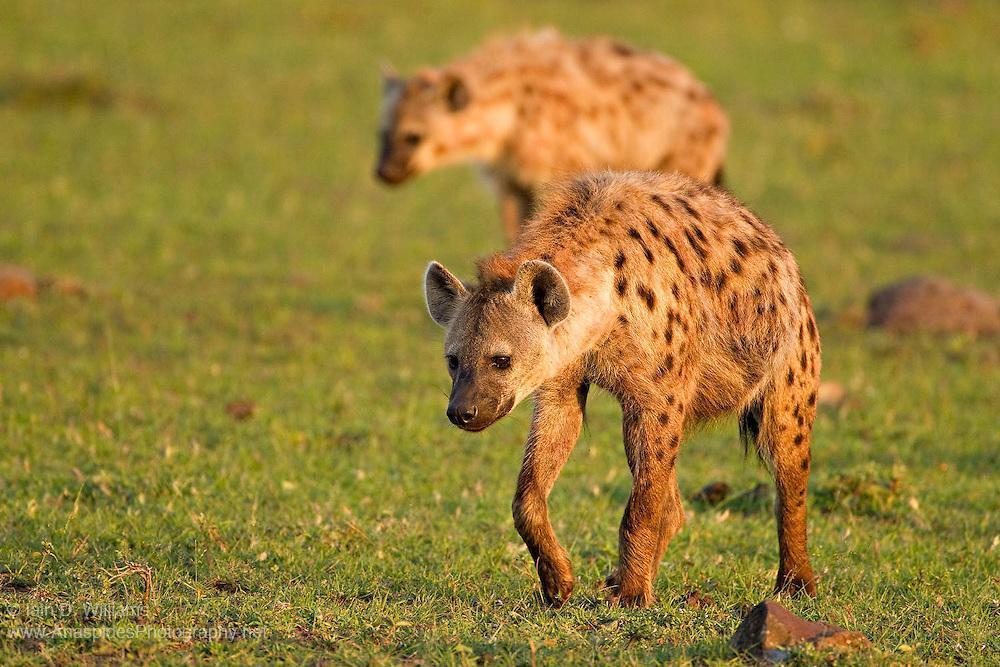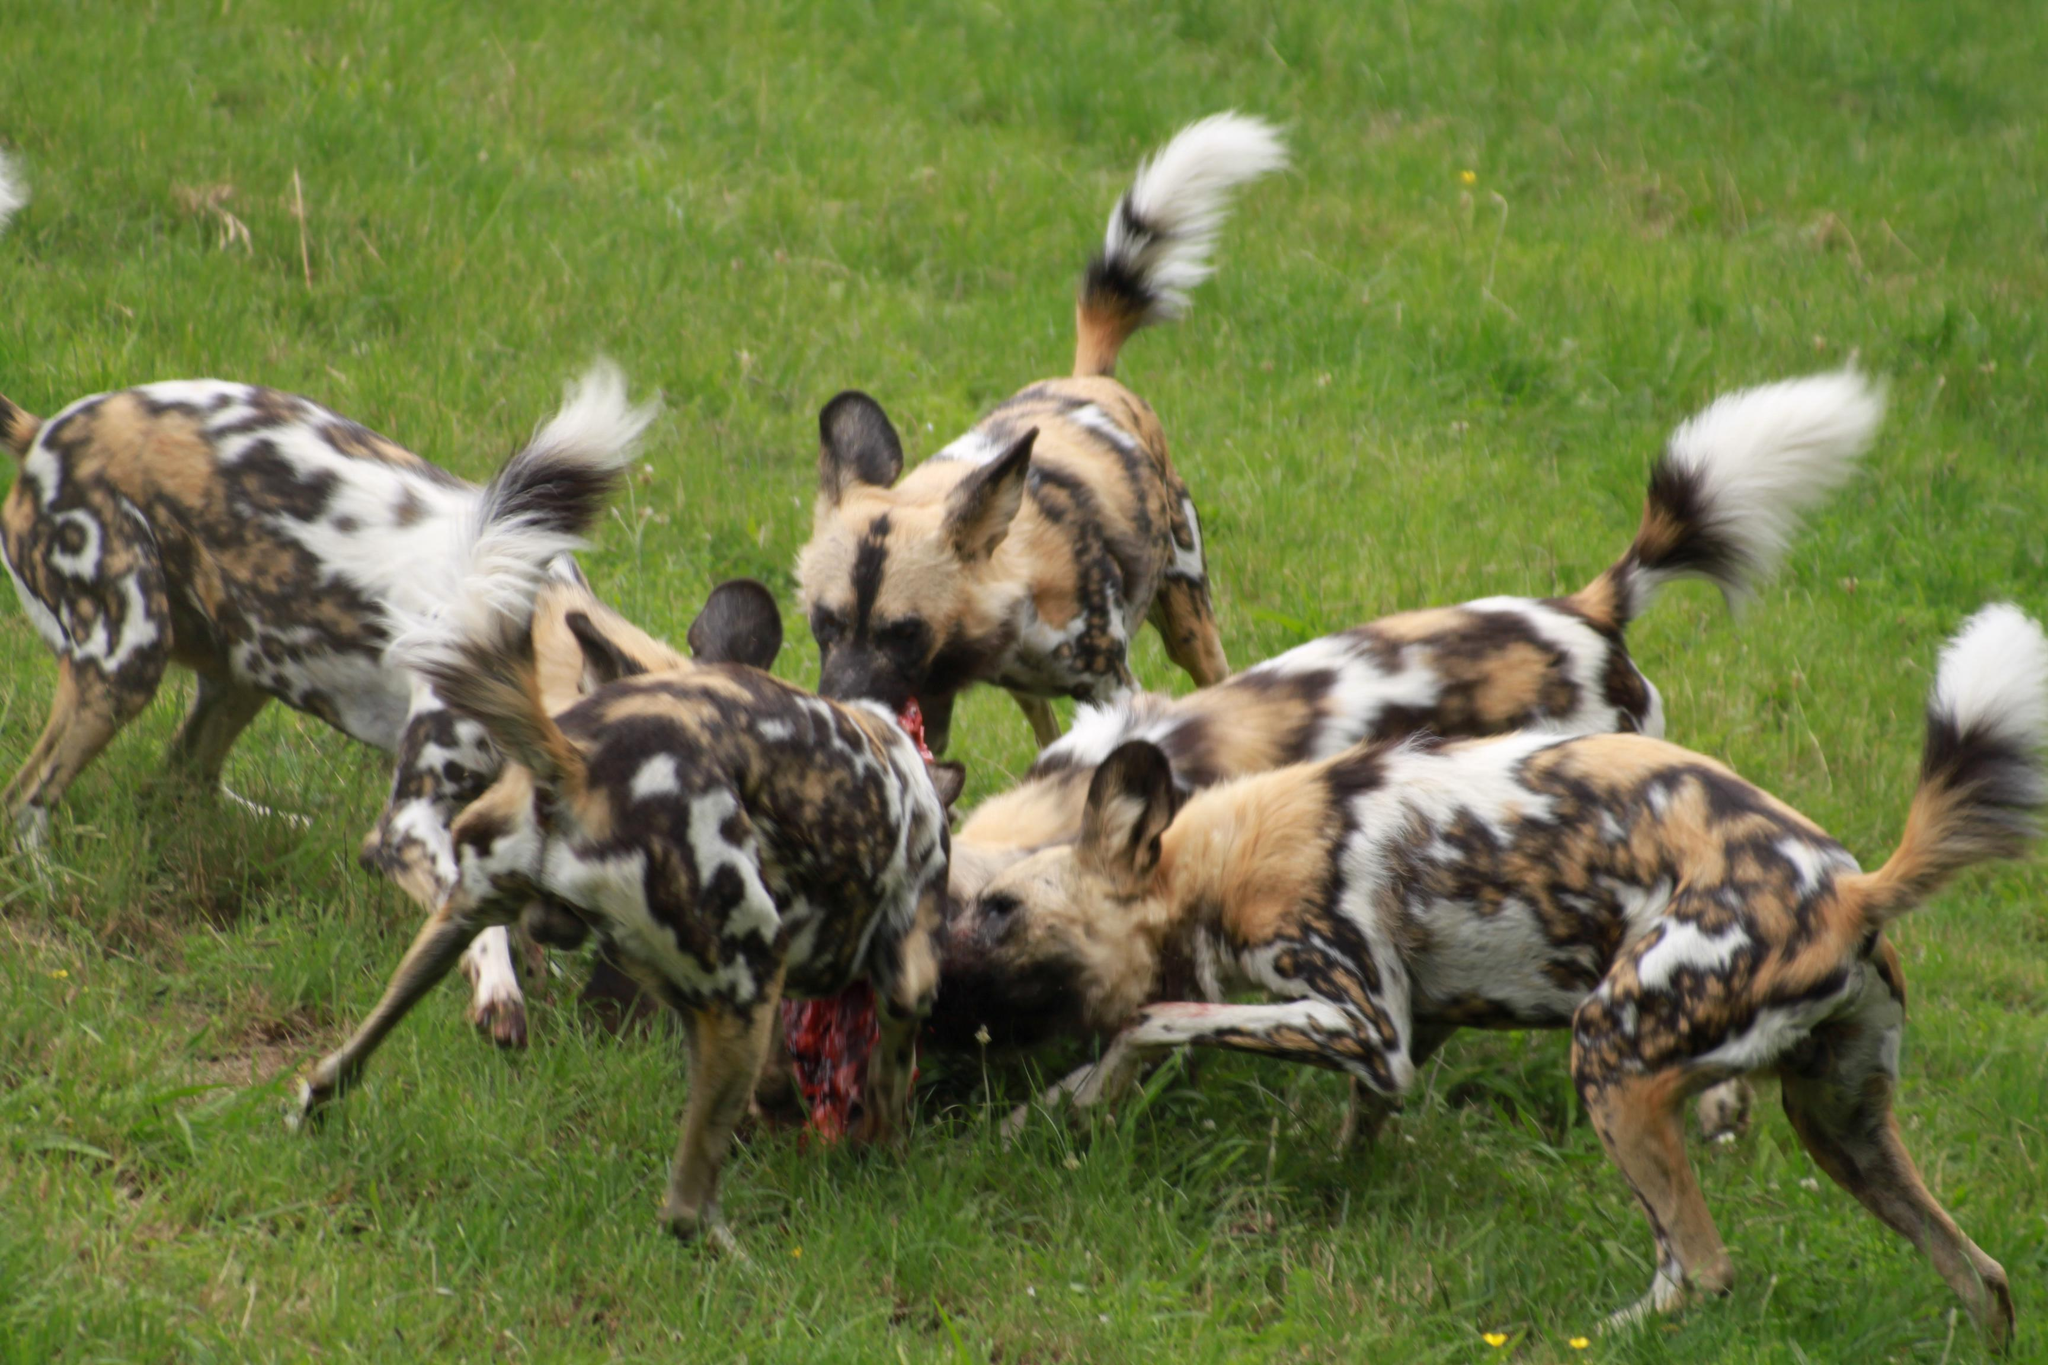The first image is the image on the left, the second image is the image on the right. Assess this claim about the two images: "There are three hyenas in the left image.". Correct or not? Answer yes or no. No. The first image is the image on the left, the second image is the image on the right. Examine the images to the left and right. Is the description "The lefthand image includes a predator-type non-hooved animal besides a hyena." accurate? Answer yes or no. No. 